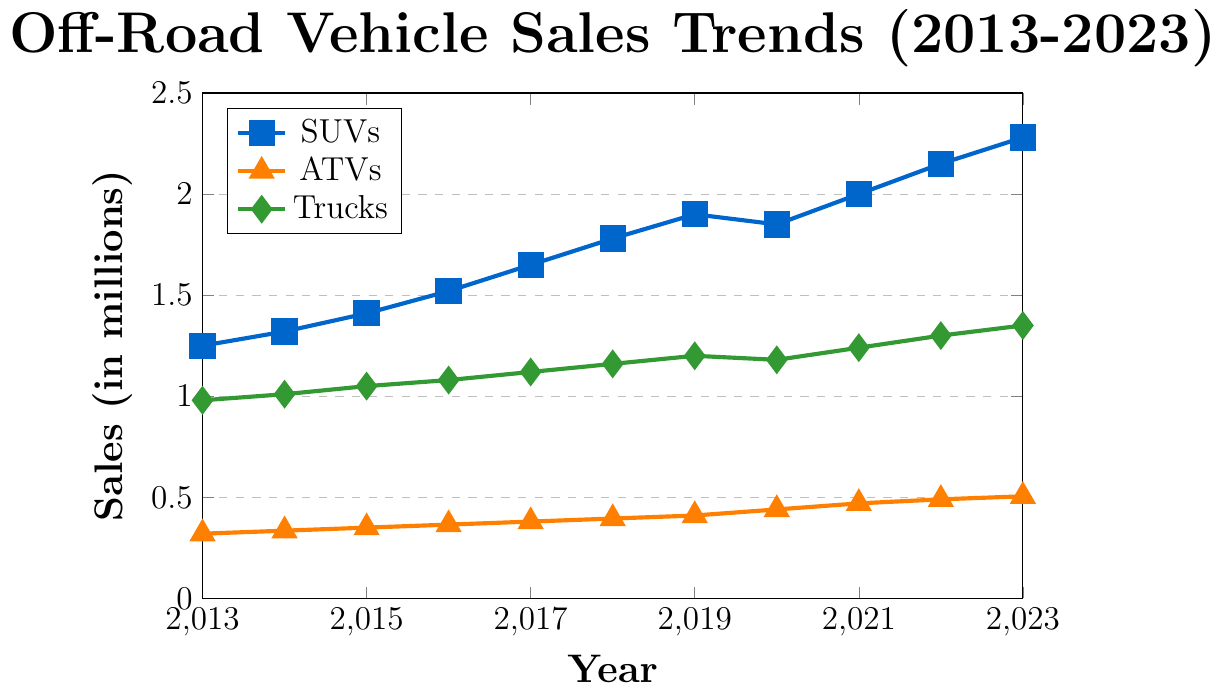What type of off-road vehicle had the highest sales in 2023? Observe the highest points on the y-axis in 2023. The SUV category is the highest among all.
Answer: SUVs What year did ATVs sales surpass 400,000 units? Look for the year when the ATV line reaches just above 0.4 million units on the y-axis.
Answer: 2020 How much did truck sales increase from 2013 to 2023? Determine the difference in truck sales between 2023 and 2013 by subtracting the 2013 value from the 2023 value (1,350,000 - 980,000 = 370,000).
Answer: 370,000 In which year did SUV sales experience a dip? Check for a year where there's a noticeable drop in the SUV sales trend. Sales dropped slightly from 2019 (1,900,000) to 2020 (1,850,000).
Answer: 2020 What is the average annual increase in ATV sales from 2013 to 2023? Calculate the annual increase by subtracting the 2013 sales from the 2023 sales, then divide by the number of years: (505,000 - 320,000) / 10 = 18,500 units per year.
Answer: 18,500 Which type of vehicle showed the greatest increase in sales from 2019 to 2023? Compare the increases for each type of vehicle: SUVs (2,280,000 - 1,900,000 = 380,000), ATVs (505,000 - 410,000 = 95,000), Trucks (1,350,000 - 1,200,000 = 150,000).
Answer: SUVs Between 2013 and 2018, which vehicle type saw the highest percentage increase in sales? Calculate the percentage increase for each vehicle from 2013 to 2018: SUVs [(1,780,000 - 1,250,000) / 1,250,000 ≈ 42.4%], ATVs [(395,000 - 320,000) / 320,000 ≈ 23.4%], Trucks [(1,160,000 - 980,000) / 980,000 ≈ 18.4%]. SUVs saw the highest increase.
Answer: SUVs How did the sales trends of trucks and SUVs compare between 2016 and 2017? Observe the slopes of the lines between 2016 and 2017 for trucks and SUVs. Full year values are SUVs (1,520,000 to 1,650,000 = +130,000), trucks (1,080,000 to 1,120,000 = +40,000).
Answer: SUVs increased more Which vehicle showed a constant increase in sales every year from 2013 to 2023? Check the lines for steady upward trends each year without dips. The SUV and ATV lines both show consistent yearly increases, although SUVs have a slight dip in 2020.
Answer: ATVs 